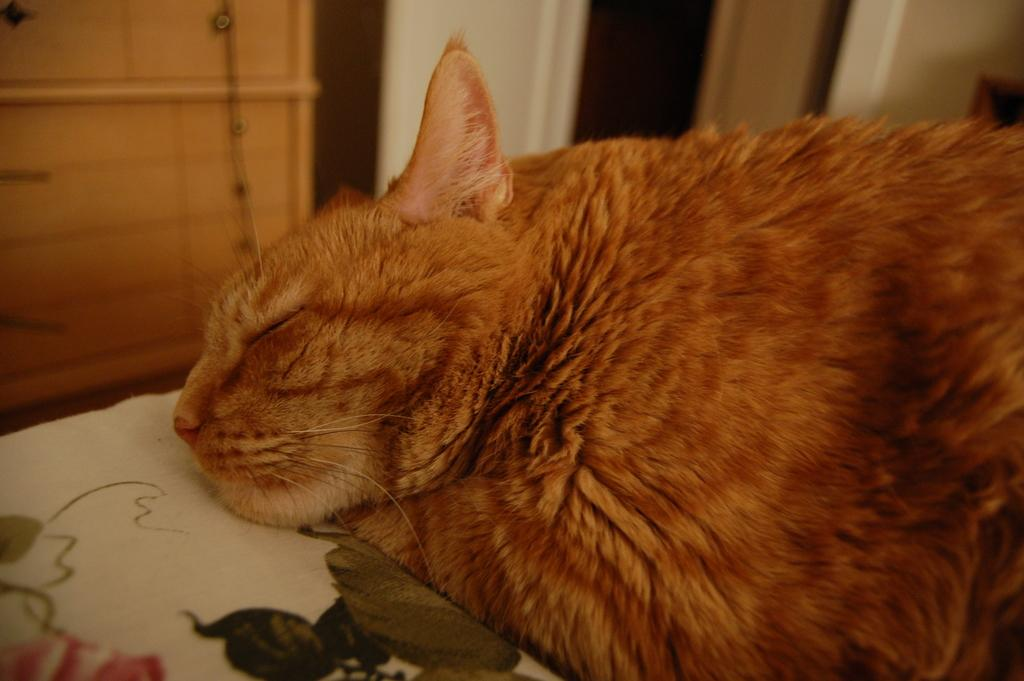What animal can be seen on the bed in the image? There is a cat lying on the bed. What type of furniture is present in the image? There is a wooden table in the image. Can you describe the background of the image? The background of the image is blurred. What type of pain is the cat experiencing in the image? There is no indication in the image that the cat is experiencing any pain. 